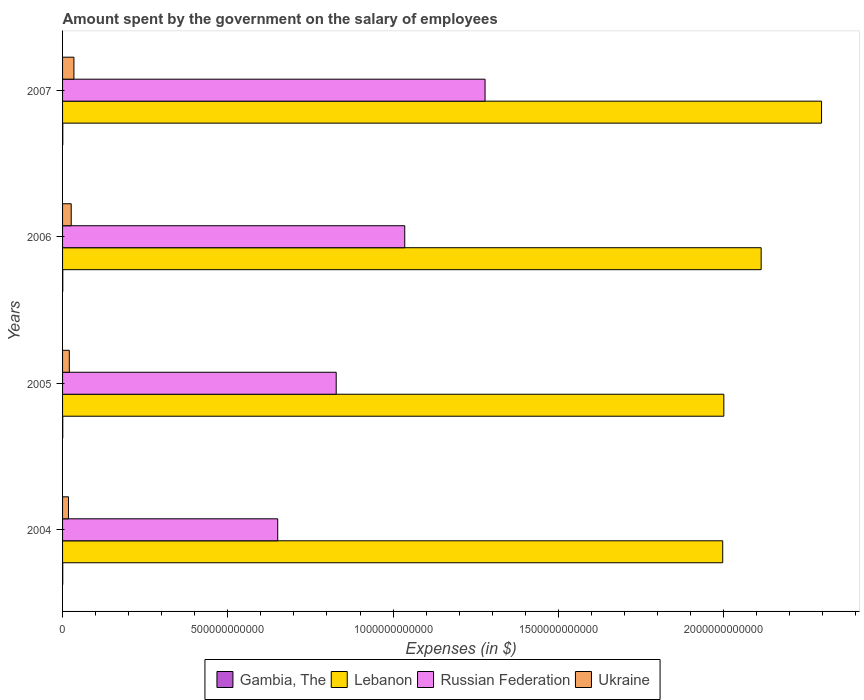What is the label of the 1st group of bars from the top?
Provide a short and direct response. 2007. In how many cases, is the number of bars for a given year not equal to the number of legend labels?
Give a very brief answer. 0. What is the amount spent on the salary of employees by the government in Russian Federation in 2004?
Provide a short and direct response. 6.51e+11. Across all years, what is the maximum amount spent on the salary of employees by the government in Russian Federation?
Provide a succinct answer. 1.28e+12. Across all years, what is the minimum amount spent on the salary of employees by the government in Lebanon?
Offer a very short reply. 2.00e+12. What is the total amount spent on the salary of employees by the government in Ukraine in the graph?
Keep it short and to the point. 9.88e+1. What is the difference between the amount spent on the salary of employees by the government in Lebanon in 2004 and that in 2006?
Provide a short and direct response. -1.16e+11. What is the difference between the amount spent on the salary of employees by the government in Russian Federation in 2004 and the amount spent on the salary of employees by the government in Gambia, The in 2007?
Offer a very short reply. 6.50e+11. What is the average amount spent on the salary of employees by the government in Gambia, The per year?
Your answer should be compact. 6.00e+08. In the year 2006, what is the difference between the amount spent on the salary of employees by the government in Lebanon and amount spent on the salary of employees by the government in Gambia, The?
Provide a short and direct response. 2.11e+12. What is the ratio of the amount spent on the salary of employees by the government in Lebanon in 2006 to that in 2007?
Offer a very short reply. 0.92. Is the difference between the amount spent on the salary of employees by the government in Lebanon in 2005 and 2007 greater than the difference between the amount spent on the salary of employees by the government in Gambia, The in 2005 and 2007?
Provide a succinct answer. No. What is the difference between the highest and the second highest amount spent on the salary of employees by the government in Gambia, The?
Offer a terse response. 2.79e+07. What is the difference between the highest and the lowest amount spent on the salary of employees by the government in Gambia, The?
Your answer should be very brief. 1.63e+08. In how many years, is the amount spent on the salary of employees by the government in Russian Federation greater than the average amount spent on the salary of employees by the government in Russian Federation taken over all years?
Offer a terse response. 2. What does the 4th bar from the top in 2006 represents?
Ensure brevity in your answer.  Gambia, The. What does the 3rd bar from the bottom in 2006 represents?
Provide a short and direct response. Russian Federation. Is it the case that in every year, the sum of the amount spent on the salary of employees by the government in Gambia, The and amount spent on the salary of employees by the government in Ukraine is greater than the amount spent on the salary of employees by the government in Russian Federation?
Provide a succinct answer. No. How many bars are there?
Your answer should be compact. 16. What is the difference between two consecutive major ticks on the X-axis?
Offer a very short reply. 5.00e+11. Are the values on the major ticks of X-axis written in scientific E-notation?
Give a very brief answer. No. Does the graph contain any zero values?
Your response must be concise. No. Does the graph contain grids?
Offer a very short reply. No. Where does the legend appear in the graph?
Keep it short and to the point. Bottom center. How are the legend labels stacked?
Provide a succinct answer. Horizontal. What is the title of the graph?
Ensure brevity in your answer.  Amount spent by the government on the salary of employees. What is the label or title of the X-axis?
Your response must be concise. Expenses (in $). What is the label or title of the Y-axis?
Offer a terse response. Years. What is the Expenses (in $) in Gambia, The in 2004?
Keep it short and to the point. 5.18e+08. What is the Expenses (in $) in Lebanon in 2004?
Provide a succinct answer. 2.00e+12. What is the Expenses (in $) of Russian Federation in 2004?
Offer a terse response. 6.51e+11. What is the Expenses (in $) of Ukraine in 2004?
Make the answer very short. 1.79e+1. What is the Expenses (in $) of Gambia, The in 2005?
Provide a succinct answer. 5.50e+08. What is the Expenses (in $) of Lebanon in 2005?
Your response must be concise. 2.00e+12. What is the Expenses (in $) in Russian Federation in 2005?
Give a very brief answer. 8.28e+11. What is the Expenses (in $) in Ukraine in 2005?
Offer a very short reply. 2.04e+1. What is the Expenses (in $) in Gambia, The in 2006?
Your response must be concise. 6.52e+08. What is the Expenses (in $) in Lebanon in 2006?
Provide a succinct answer. 2.11e+12. What is the Expenses (in $) of Russian Federation in 2006?
Your response must be concise. 1.04e+12. What is the Expenses (in $) in Ukraine in 2006?
Give a very brief answer. 2.62e+1. What is the Expenses (in $) in Gambia, The in 2007?
Give a very brief answer. 6.80e+08. What is the Expenses (in $) in Lebanon in 2007?
Your response must be concise. 2.30e+12. What is the Expenses (in $) of Russian Federation in 2007?
Provide a short and direct response. 1.28e+12. What is the Expenses (in $) in Ukraine in 2007?
Offer a very short reply. 3.44e+1. Across all years, what is the maximum Expenses (in $) in Gambia, The?
Provide a short and direct response. 6.80e+08. Across all years, what is the maximum Expenses (in $) of Lebanon?
Keep it short and to the point. 2.30e+12. Across all years, what is the maximum Expenses (in $) of Russian Federation?
Ensure brevity in your answer.  1.28e+12. Across all years, what is the maximum Expenses (in $) of Ukraine?
Ensure brevity in your answer.  3.44e+1. Across all years, what is the minimum Expenses (in $) of Gambia, The?
Provide a short and direct response. 5.18e+08. Across all years, what is the minimum Expenses (in $) in Lebanon?
Your answer should be very brief. 2.00e+12. Across all years, what is the minimum Expenses (in $) in Russian Federation?
Your response must be concise. 6.51e+11. Across all years, what is the minimum Expenses (in $) in Ukraine?
Keep it short and to the point. 1.79e+1. What is the total Expenses (in $) in Gambia, The in the graph?
Provide a short and direct response. 2.40e+09. What is the total Expenses (in $) of Lebanon in the graph?
Provide a short and direct response. 8.41e+12. What is the total Expenses (in $) of Russian Federation in the graph?
Give a very brief answer. 3.79e+12. What is the total Expenses (in $) in Ukraine in the graph?
Keep it short and to the point. 9.88e+1. What is the difference between the Expenses (in $) in Gambia, The in 2004 and that in 2005?
Give a very brief answer. -3.18e+07. What is the difference between the Expenses (in $) in Lebanon in 2004 and that in 2005?
Keep it short and to the point. -3.43e+09. What is the difference between the Expenses (in $) in Russian Federation in 2004 and that in 2005?
Offer a very short reply. -1.77e+11. What is the difference between the Expenses (in $) of Ukraine in 2004 and that in 2005?
Your answer should be compact. -2.53e+09. What is the difference between the Expenses (in $) in Gambia, The in 2004 and that in 2006?
Keep it short and to the point. -1.35e+08. What is the difference between the Expenses (in $) in Lebanon in 2004 and that in 2006?
Offer a terse response. -1.16e+11. What is the difference between the Expenses (in $) of Russian Federation in 2004 and that in 2006?
Ensure brevity in your answer.  -3.84e+11. What is the difference between the Expenses (in $) in Ukraine in 2004 and that in 2006?
Make the answer very short. -8.30e+09. What is the difference between the Expenses (in $) of Gambia, The in 2004 and that in 2007?
Ensure brevity in your answer.  -1.63e+08. What is the difference between the Expenses (in $) of Lebanon in 2004 and that in 2007?
Your response must be concise. -2.99e+11. What is the difference between the Expenses (in $) in Russian Federation in 2004 and that in 2007?
Give a very brief answer. -6.27e+11. What is the difference between the Expenses (in $) of Ukraine in 2004 and that in 2007?
Offer a terse response. -1.65e+1. What is the difference between the Expenses (in $) of Gambia, The in 2005 and that in 2006?
Your answer should be very brief. -1.03e+08. What is the difference between the Expenses (in $) of Lebanon in 2005 and that in 2006?
Offer a terse response. -1.13e+11. What is the difference between the Expenses (in $) of Russian Federation in 2005 and that in 2006?
Ensure brevity in your answer.  -2.07e+11. What is the difference between the Expenses (in $) of Ukraine in 2005 and that in 2006?
Provide a short and direct response. -5.76e+09. What is the difference between the Expenses (in $) in Gambia, The in 2005 and that in 2007?
Provide a short and direct response. -1.31e+08. What is the difference between the Expenses (in $) of Lebanon in 2005 and that in 2007?
Ensure brevity in your answer.  -2.96e+11. What is the difference between the Expenses (in $) in Russian Federation in 2005 and that in 2007?
Give a very brief answer. -4.50e+11. What is the difference between the Expenses (in $) of Ukraine in 2005 and that in 2007?
Offer a terse response. -1.39e+1. What is the difference between the Expenses (in $) of Gambia, The in 2006 and that in 2007?
Your answer should be compact. -2.79e+07. What is the difference between the Expenses (in $) of Lebanon in 2006 and that in 2007?
Keep it short and to the point. -1.83e+11. What is the difference between the Expenses (in $) in Russian Federation in 2006 and that in 2007?
Your response must be concise. -2.43e+11. What is the difference between the Expenses (in $) in Ukraine in 2006 and that in 2007?
Offer a very short reply. -8.18e+09. What is the difference between the Expenses (in $) in Gambia, The in 2004 and the Expenses (in $) in Lebanon in 2005?
Make the answer very short. -2.00e+12. What is the difference between the Expenses (in $) of Gambia, The in 2004 and the Expenses (in $) of Russian Federation in 2005?
Offer a terse response. -8.27e+11. What is the difference between the Expenses (in $) of Gambia, The in 2004 and the Expenses (in $) of Ukraine in 2005?
Give a very brief answer. -1.99e+1. What is the difference between the Expenses (in $) in Lebanon in 2004 and the Expenses (in $) in Russian Federation in 2005?
Your answer should be compact. 1.17e+12. What is the difference between the Expenses (in $) of Lebanon in 2004 and the Expenses (in $) of Ukraine in 2005?
Provide a succinct answer. 1.98e+12. What is the difference between the Expenses (in $) of Russian Federation in 2004 and the Expenses (in $) of Ukraine in 2005?
Offer a terse response. 6.31e+11. What is the difference between the Expenses (in $) of Gambia, The in 2004 and the Expenses (in $) of Lebanon in 2006?
Ensure brevity in your answer.  -2.11e+12. What is the difference between the Expenses (in $) in Gambia, The in 2004 and the Expenses (in $) in Russian Federation in 2006?
Your answer should be very brief. -1.03e+12. What is the difference between the Expenses (in $) in Gambia, The in 2004 and the Expenses (in $) in Ukraine in 2006?
Your answer should be compact. -2.57e+1. What is the difference between the Expenses (in $) of Lebanon in 2004 and the Expenses (in $) of Russian Federation in 2006?
Offer a very short reply. 9.62e+11. What is the difference between the Expenses (in $) of Lebanon in 2004 and the Expenses (in $) of Ukraine in 2006?
Offer a very short reply. 1.97e+12. What is the difference between the Expenses (in $) in Russian Federation in 2004 and the Expenses (in $) in Ukraine in 2006?
Ensure brevity in your answer.  6.25e+11. What is the difference between the Expenses (in $) in Gambia, The in 2004 and the Expenses (in $) in Lebanon in 2007?
Provide a succinct answer. -2.30e+12. What is the difference between the Expenses (in $) of Gambia, The in 2004 and the Expenses (in $) of Russian Federation in 2007?
Your answer should be very brief. -1.28e+12. What is the difference between the Expenses (in $) of Gambia, The in 2004 and the Expenses (in $) of Ukraine in 2007?
Your answer should be very brief. -3.38e+1. What is the difference between the Expenses (in $) in Lebanon in 2004 and the Expenses (in $) in Russian Federation in 2007?
Your response must be concise. 7.19e+11. What is the difference between the Expenses (in $) of Lebanon in 2004 and the Expenses (in $) of Ukraine in 2007?
Your answer should be very brief. 1.96e+12. What is the difference between the Expenses (in $) in Russian Federation in 2004 and the Expenses (in $) in Ukraine in 2007?
Your response must be concise. 6.17e+11. What is the difference between the Expenses (in $) of Gambia, The in 2005 and the Expenses (in $) of Lebanon in 2006?
Your response must be concise. -2.11e+12. What is the difference between the Expenses (in $) of Gambia, The in 2005 and the Expenses (in $) of Russian Federation in 2006?
Your answer should be very brief. -1.03e+12. What is the difference between the Expenses (in $) of Gambia, The in 2005 and the Expenses (in $) of Ukraine in 2006?
Give a very brief answer. -2.56e+1. What is the difference between the Expenses (in $) of Lebanon in 2005 and the Expenses (in $) of Russian Federation in 2006?
Offer a terse response. 9.66e+11. What is the difference between the Expenses (in $) of Lebanon in 2005 and the Expenses (in $) of Ukraine in 2006?
Your answer should be compact. 1.97e+12. What is the difference between the Expenses (in $) of Russian Federation in 2005 and the Expenses (in $) of Ukraine in 2006?
Keep it short and to the point. 8.02e+11. What is the difference between the Expenses (in $) in Gambia, The in 2005 and the Expenses (in $) in Lebanon in 2007?
Keep it short and to the point. -2.30e+12. What is the difference between the Expenses (in $) in Gambia, The in 2005 and the Expenses (in $) in Russian Federation in 2007?
Provide a short and direct response. -1.28e+12. What is the difference between the Expenses (in $) of Gambia, The in 2005 and the Expenses (in $) of Ukraine in 2007?
Provide a succinct answer. -3.38e+1. What is the difference between the Expenses (in $) in Lebanon in 2005 and the Expenses (in $) in Russian Federation in 2007?
Offer a very short reply. 7.23e+11. What is the difference between the Expenses (in $) of Lebanon in 2005 and the Expenses (in $) of Ukraine in 2007?
Provide a succinct answer. 1.97e+12. What is the difference between the Expenses (in $) in Russian Federation in 2005 and the Expenses (in $) in Ukraine in 2007?
Provide a short and direct response. 7.94e+11. What is the difference between the Expenses (in $) in Gambia, The in 2006 and the Expenses (in $) in Lebanon in 2007?
Offer a terse response. -2.30e+12. What is the difference between the Expenses (in $) of Gambia, The in 2006 and the Expenses (in $) of Russian Federation in 2007?
Provide a short and direct response. -1.28e+12. What is the difference between the Expenses (in $) of Gambia, The in 2006 and the Expenses (in $) of Ukraine in 2007?
Give a very brief answer. -3.37e+1. What is the difference between the Expenses (in $) of Lebanon in 2006 and the Expenses (in $) of Russian Federation in 2007?
Your answer should be compact. 8.35e+11. What is the difference between the Expenses (in $) in Lebanon in 2006 and the Expenses (in $) in Ukraine in 2007?
Your answer should be very brief. 2.08e+12. What is the difference between the Expenses (in $) of Russian Federation in 2006 and the Expenses (in $) of Ukraine in 2007?
Offer a terse response. 1.00e+12. What is the average Expenses (in $) in Gambia, The per year?
Provide a succinct answer. 6.00e+08. What is the average Expenses (in $) in Lebanon per year?
Provide a short and direct response. 2.10e+12. What is the average Expenses (in $) of Russian Federation per year?
Your response must be concise. 9.48e+11. What is the average Expenses (in $) in Ukraine per year?
Offer a terse response. 2.47e+1. In the year 2004, what is the difference between the Expenses (in $) in Gambia, The and Expenses (in $) in Lebanon?
Your answer should be compact. -2.00e+12. In the year 2004, what is the difference between the Expenses (in $) in Gambia, The and Expenses (in $) in Russian Federation?
Provide a succinct answer. -6.50e+11. In the year 2004, what is the difference between the Expenses (in $) in Gambia, The and Expenses (in $) in Ukraine?
Give a very brief answer. -1.74e+1. In the year 2004, what is the difference between the Expenses (in $) in Lebanon and Expenses (in $) in Russian Federation?
Give a very brief answer. 1.35e+12. In the year 2004, what is the difference between the Expenses (in $) in Lebanon and Expenses (in $) in Ukraine?
Give a very brief answer. 1.98e+12. In the year 2004, what is the difference between the Expenses (in $) in Russian Federation and Expenses (in $) in Ukraine?
Your response must be concise. 6.33e+11. In the year 2005, what is the difference between the Expenses (in $) in Gambia, The and Expenses (in $) in Lebanon?
Provide a short and direct response. -2.00e+12. In the year 2005, what is the difference between the Expenses (in $) of Gambia, The and Expenses (in $) of Russian Federation?
Give a very brief answer. -8.27e+11. In the year 2005, what is the difference between the Expenses (in $) in Gambia, The and Expenses (in $) in Ukraine?
Offer a very short reply. -1.99e+1. In the year 2005, what is the difference between the Expenses (in $) of Lebanon and Expenses (in $) of Russian Federation?
Ensure brevity in your answer.  1.17e+12. In the year 2005, what is the difference between the Expenses (in $) of Lebanon and Expenses (in $) of Ukraine?
Ensure brevity in your answer.  1.98e+12. In the year 2005, what is the difference between the Expenses (in $) of Russian Federation and Expenses (in $) of Ukraine?
Your response must be concise. 8.08e+11. In the year 2006, what is the difference between the Expenses (in $) in Gambia, The and Expenses (in $) in Lebanon?
Offer a terse response. -2.11e+12. In the year 2006, what is the difference between the Expenses (in $) of Gambia, The and Expenses (in $) of Russian Federation?
Your answer should be compact. -1.03e+12. In the year 2006, what is the difference between the Expenses (in $) of Gambia, The and Expenses (in $) of Ukraine?
Provide a succinct answer. -2.55e+1. In the year 2006, what is the difference between the Expenses (in $) of Lebanon and Expenses (in $) of Russian Federation?
Provide a succinct answer. 1.08e+12. In the year 2006, what is the difference between the Expenses (in $) of Lebanon and Expenses (in $) of Ukraine?
Offer a terse response. 2.09e+12. In the year 2006, what is the difference between the Expenses (in $) in Russian Federation and Expenses (in $) in Ukraine?
Make the answer very short. 1.01e+12. In the year 2007, what is the difference between the Expenses (in $) in Gambia, The and Expenses (in $) in Lebanon?
Offer a terse response. -2.30e+12. In the year 2007, what is the difference between the Expenses (in $) in Gambia, The and Expenses (in $) in Russian Federation?
Ensure brevity in your answer.  -1.28e+12. In the year 2007, what is the difference between the Expenses (in $) of Gambia, The and Expenses (in $) of Ukraine?
Make the answer very short. -3.37e+1. In the year 2007, what is the difference between the Expenses (in $) in Lebanon and Expenses (in $) in Russian Federation?
Make the answer very short. 1.02e+12. In the year 2007, what is the difference between the Expenses (in $) in Lebanon and Expenses (in $) in Ukraine?
Keep it short and to the point. 2.26e+12. In the year 2007, what is the difference between the Expenses (in $) in Russian Federation and Expenses (in $) in Ukraine?
Keep it short and to the point. 1.24e+12. What is the ratio of the Expenses (in $) of Gambia, The in 2004 to that in 2005?
Your answer should be compact. 0.94. What is the ratio of the Expenses (in $) in Lebanon in 2004 to that in 2005?
Make the answer very short. 1. What is the ratio of the Expenses (in $) in Russian Federation in 2004 to that in 2005?
Offer a terse response. 0.79. What is the ratio of the Expenses (in $) in Ukraine in 2004 to that in 2005?
Give a very brief answer. 0.88. What is the ratio of the Expenses (in $) of Gambia, The in 2004 to that in 2006?
Provide a succinct answer. 0.79. What is the ratio of the Expenses (in $) in Lebanon in 2004 to that in 2006?
Provide a succinct answer. 0.94. What is the ratio of the Expenses (in $) in Russian Federation in 2004 to that in 2006?
Make the answer very short. 0.63. What is the ratio of the Expenses (in $) in Ukraine in 2004 to that in 2006?
Your answer should be very brief. 0.68. What is the ratio of the Expenses (in $) in Gambia, The in 2004 to that in 2007?
Offer a very short reply. 0.76. What is the ratio of the Expenses (in $) in Lebanon in 2004 to that in 2007?
Provide a short and direct response. 0.87. What is the ratio of the Expenses (in $) in Russian Federation in 2004 to that in 2007?
Your answer should be very brief. 0.51. What is the ratio of the Expenses (in $) in Ukraine in 2004 to that in 2007?
Your answer should be compact. 0.52. What is the ratio of the Expenses (in $) in Gambia, The in 2005 to that in 2006?
Provide a short and direct response. 0.84. What is the ratio of the Expenses (in $) in Lebanon in 2005 to that in 2006?
Ensure brevity in your answer.  0.95. What is the ratio of the Expenses (in $) in Russian Federation in 2005 to that in 2006?
Offer a very short reply. 0.8. What is the ratio of the Expenses (in $) in Ukraine in 2005 to that in 2006?
Your response must be concise. 0.78. What is the ratio of the Expenses (in $) of Gambia, The in 2005 to that in 2007?
Give a very brief answer. 0.81. What is the ratio of the Expenses (in $) in Lebanon in 2005 to that in 2007?
Your response must be concise. 0.87. What is the ratio of the Expenses (in $) in Russian Federation in 2005 to that in 2007?
Keep it short and to the point. 0.65. What is the ratio of the Expenses (in $) of Ukraine in 2005 to that in 2007?
Provide a short and direct response. 0.59. What is the ratio of the Expenses (in $) of Lebanon in 2006 to that in 2007?
Give a very brief answer. 0.92. What is the ratio of the Expenses (in $) in Russian Federation in 2006 to that in 2007?
Your answer should be very brief. 0.81. What is the ratio of the Expenses (in $) of Ukraine in 2006 to that in 2007?
Ensure brevity in your answer.  0.76. What is the difference between the highest and the second highest Expenses (in $) of Gambia, The?
Make the answer very short. 2.79e+07. What is the difference between the highest and the second highest Expenses (in $) in Lebanon?
Your answer should be compact. 1.83e+11. What is the difference between the highest and the second highest Expenses (in $) in Russian Federation?
Your answer should be compact. 2.43e+11. What is the difference between the highest and the second highest Expenses (in $) in Ukraine?
Make the answer very short. 8.18e+09. What is the difference between the highest and the lowest Expenses (in $) in Gambia, The?
Provide a short and direct response. 1.63e+08. What is the difference between the highest and the lowest Expenses (in $) of Lebanon?
Make the answer very short. 2.99e+11. What is the difference between the highest and the lowest Expenses (in $) in Russian Federation?
Your answer should be compact. 6.27e+11. What is the difference between the highest and the lowest Expenses (in $) in Ukraine?
Ensure brevity in your answer.  1.65e+1. 